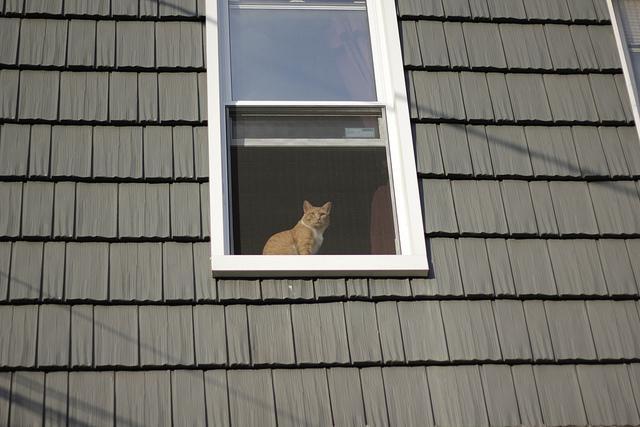How many people have long hair?
Give a very brief answer. 0. 